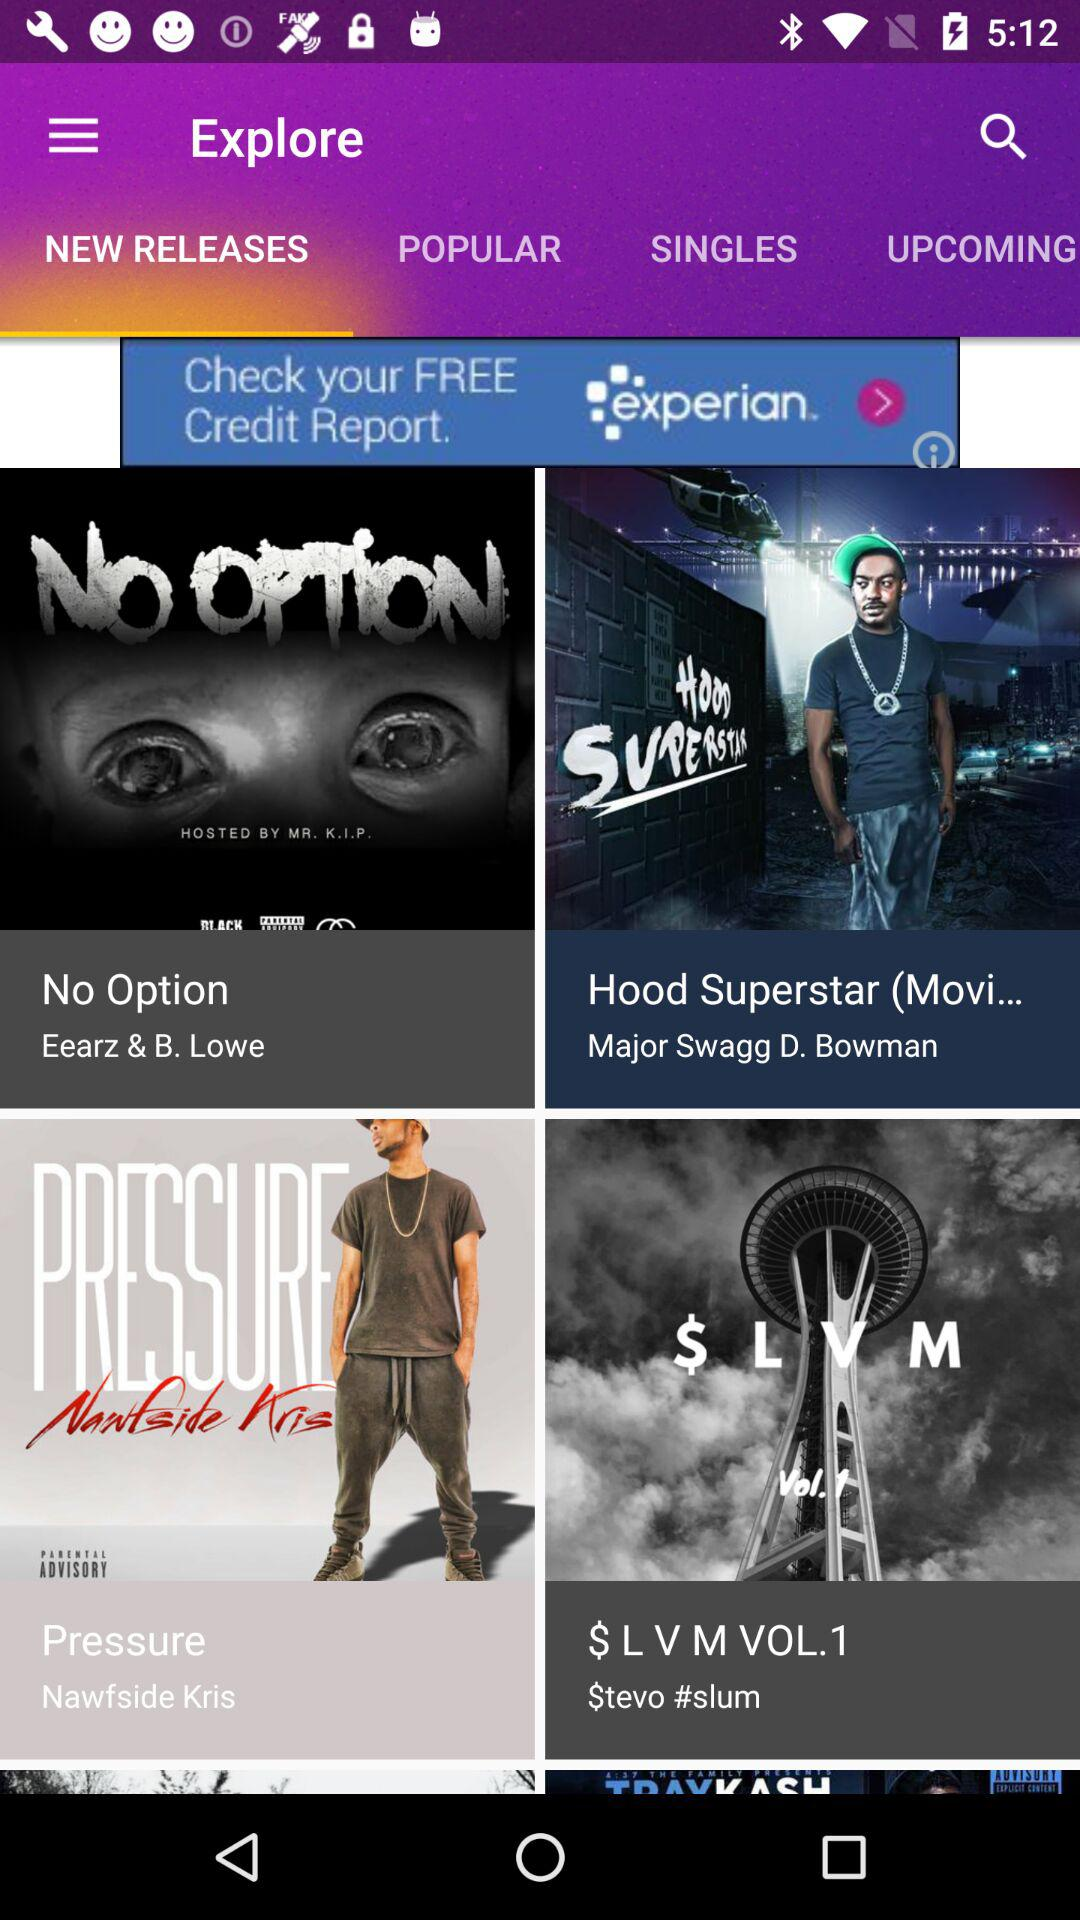Who is the artist of "Hood Superstar"? The artist of "Hood Superstar" is Major Swagg D. Bowman. 